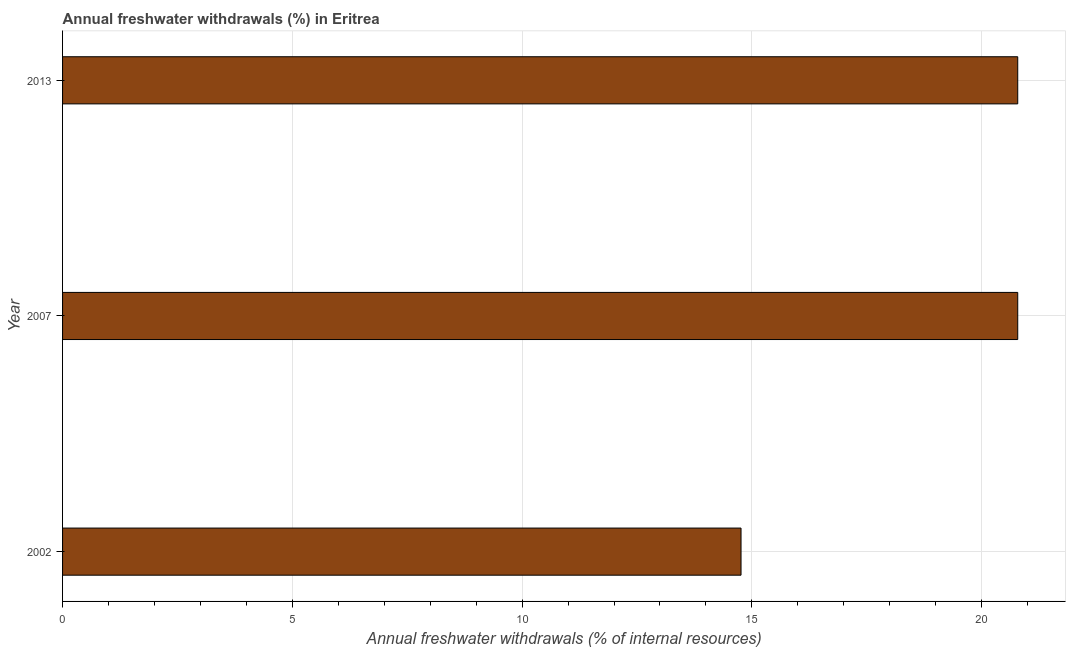Does the graph contain any zero values?
Provide a short and direct response. No. What is the title of the graph?
Your response must be concise. Annual freshwater withdrawals (%) in Eritrea. What is the label or title of the X-axis?
Ensure brevity in your answer.  Annual freshwater withdrawals (% of internal resources). What is the annual freshwater withdrawals in 2002?
Give a very brief answer. 14.76. Across all years, what is the maximum annual freshwater withdrawals?
Offer a very short reply. 20.79. Across all years, what is the minimum annual freshwater withdrawals?
Provide a short and direct response. 14.76. In which year was the annual freshwater withdrawals minimum?
Ensure brevity in your answer.  2002. What is the sum of the annual freshwater withdrawals?
Ensure brevity in your answer.  56.34. What is the difference between the annual freshwater withdrawals in 2002 and 2013?
Offer a terse response. -6.02. What is the average annual freshwater withdrawals per year?
Provide a short and direct response. 18.78. What is the median annual freshwater withdrawals?
Keep it short and to the point. 20.79. Do a majority of the years between 2007 and 2013 (inclusive) have annual freshwater withdrawals greater than 14 %?
Your response must be concise. Yes. What is the ratio of the annual freshwater withdrawals in 2002 to that in 2013?
Keep it short and to the point. 0.71. Is the annual freshwater withdrawals in 2002 less than that in 2007?
Your answer should be compact. Yes. Is the difference between the annual freshwater withdrawals in 2002 and 2007 greater than the difference between any two years?
Your answer should be compact. Yes. Is the sum of the annual freshwater withdrawals in 2002 and 2013 greater than the maximum annual freshwater withdrawals across all years?
Your response must be concise. Yes. What is the difference between the highest and the lowest annual freshwater withdrawals?
Offer a terse response. 6.02. In how many years, is the annual freshwater withdrawals greater than the average annual freshwater withdrawals taken over all years?
Your response must be concise. 2. How many bars are there?
Your response must be concise. 3. Are all the bars in the graph horizontal?
Ensure brevity in your answer.  Yes. How many years are there in the graph?
Provide a succinct answer. 3. Are the values on the major ticks of X-axis written in scientific E-notation?
Ensure brevity in your answer.  No. What is the Annual freshwater withdrawals (% of internal resources) in 2002?
Keep it short and to the point. 14.76. What is the Annual freshwater withdrawals (% of internal resources) in 2007?
Keep it short and to the point. 20.79. What is the Annual freshwater withdrawals (% of internal resources) of 2013?
Provide a succinct answer. 20.79. What is the difference between the Annual freshwater withdrawals (% of internal resources) in 2002 and 2007?
Offer a very short reply. -6.02. What is the difference between the Annual freshwater withdrawals (% of internal resources) in 2002 and 2013?
Provide a short and direct response. -6.02. What is the ratio of the Annual freshwater withdrawals (% of internal resources) in 2002 to that in 2007?
Your answer should be very brief. 0.71. What is the ratio of the Annual freshwater withdrawals (% of internal resources) in 2002 to that in 2013?
Ensure brevity in your answer.  0.71. What is the ratio of the Annual freshwater withdrawals (% of internal resources) in 2007 to that in 2013?
Make the answer very short. 1. 